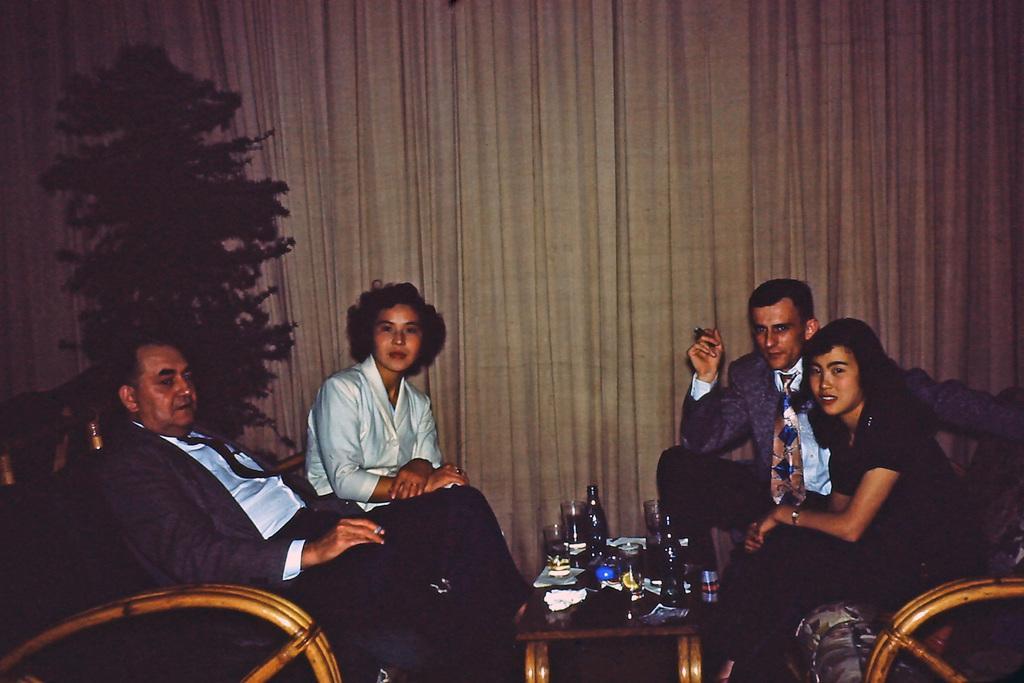In one or two sentences, can you explain what this image depicts? This image is taken indoors. In the background there are a few curtains and there is a plant. On the left side of the image a man and a woman are sitting on the chairs. On the right side of the image a girl and a man are sitting on the chairs. In the middle of the image there is a table with a few bottles, glass and many things on it. 